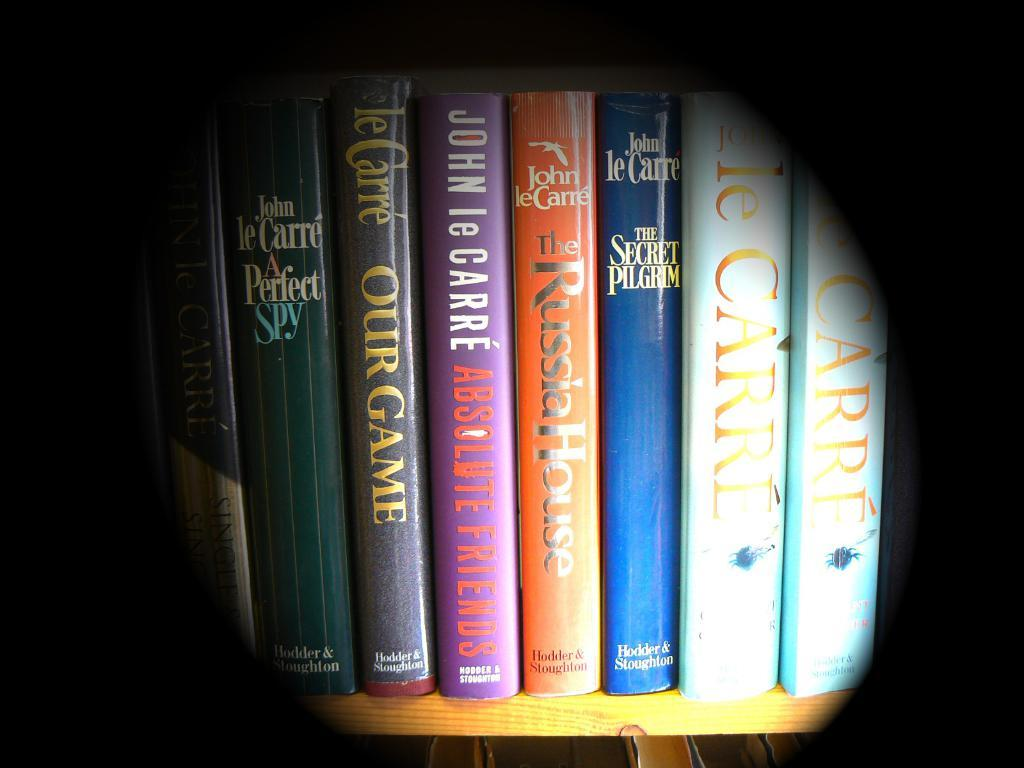<image>
Render a clear and concise summary of the photo. The image shows a shelf of books that have the genre of thrillers, espionage and mysteries. 